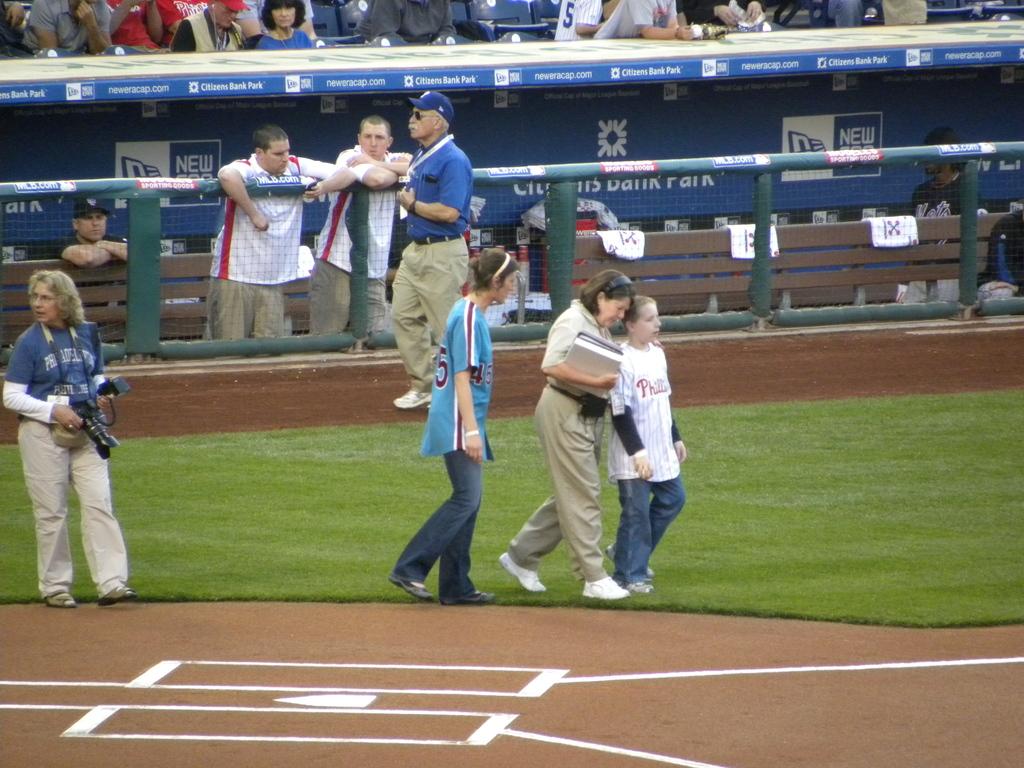What is the name of the park?
Your answer should be compact. Citizens bank park. 